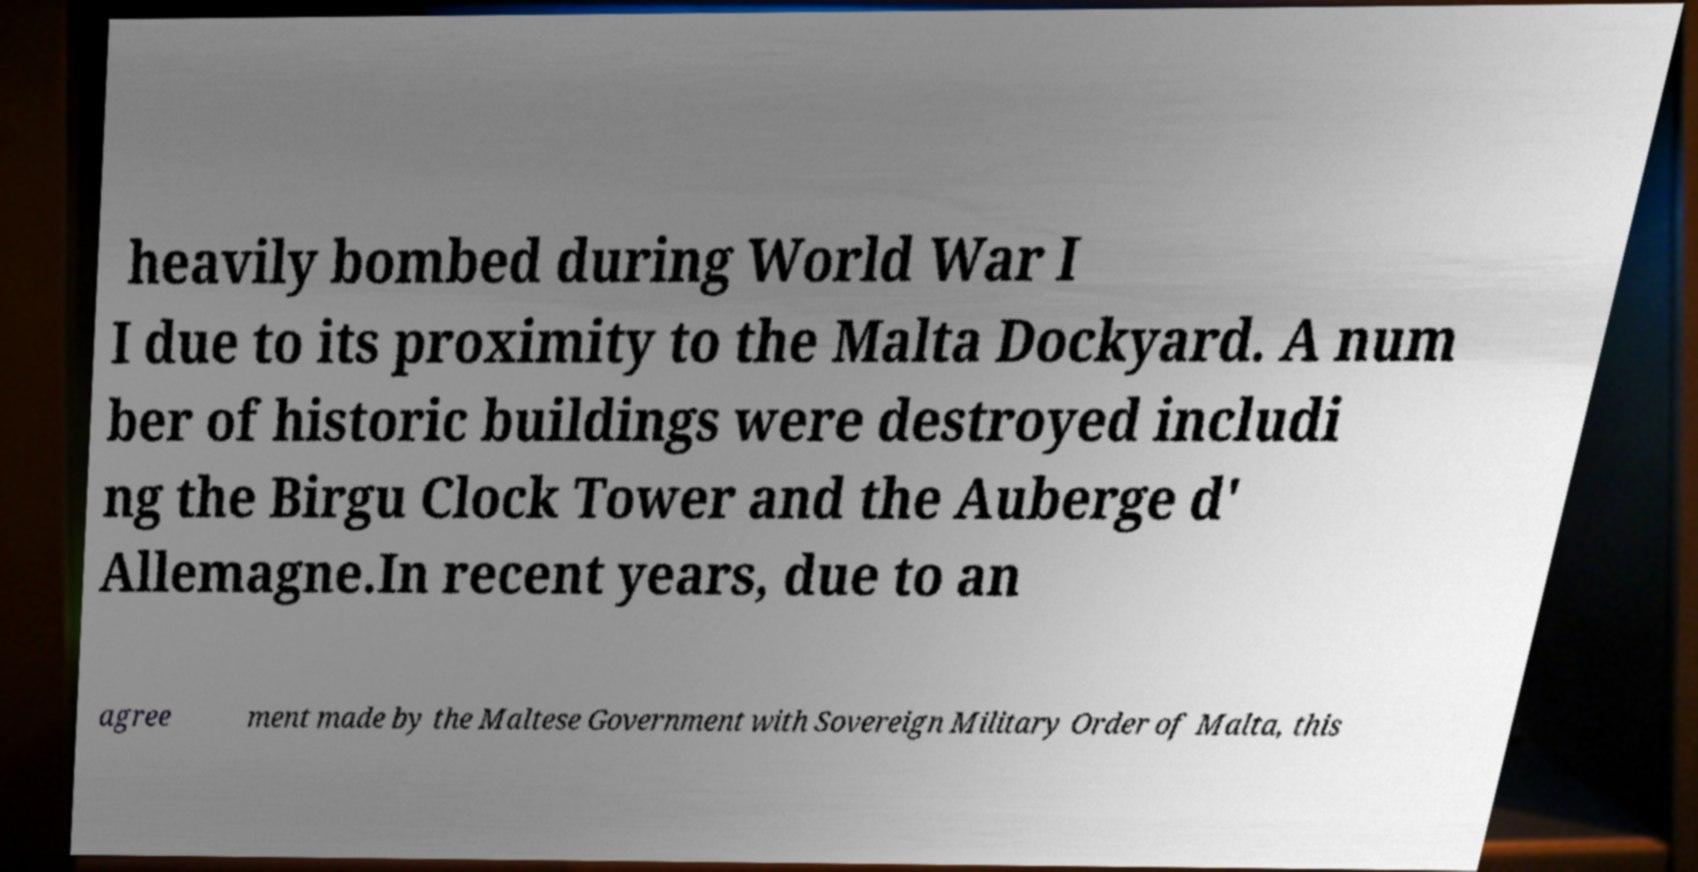Can you accurately transcribe the text from the provided image for me? heavily bombed during World War I I due to its proximity to the Malta Dockyard. A num ber of historic buildings were destroyed includi ng the Birgu Clock Tower and the Auberge d' Allemagne.In recent years, due to an agree ment made by the Maltese Government with Sovereign Military Order of Malta, this 